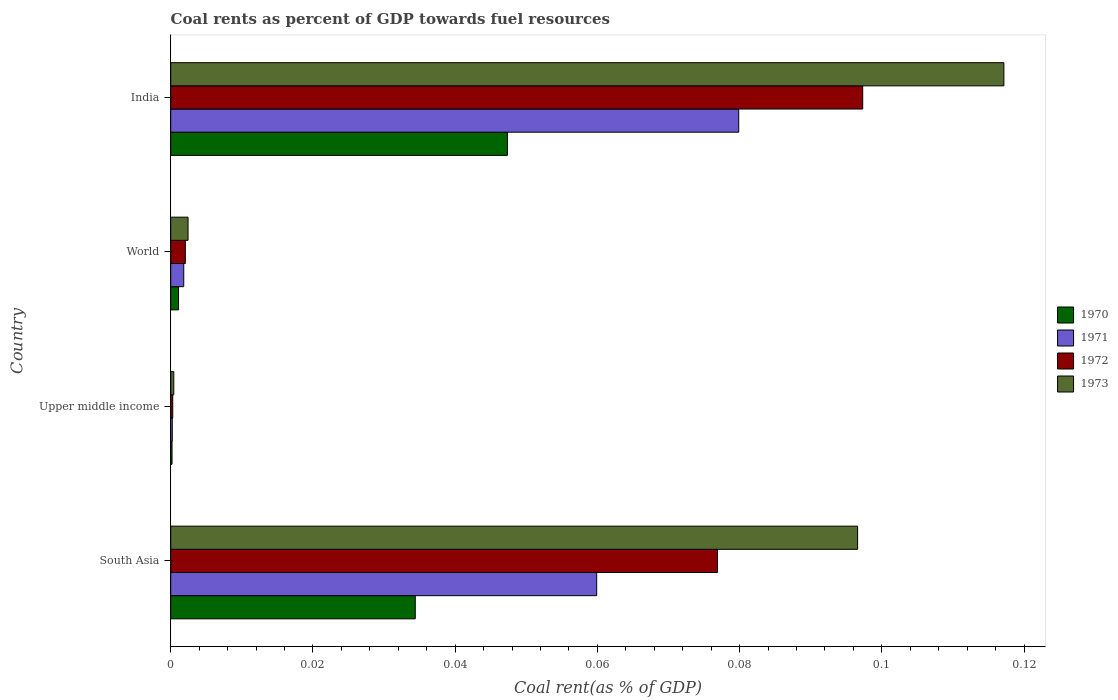How many different coloured bars are there?
Provide a succinct answer. 4. Are the number of bars per tick equal to the number of legend labels?
Your response must be concise. Yes. How many bars are there on the 1st tick from the top?
Offer a terse response. 4. How many bars are there on the 4th tick from the bottom?
Ensure brevity in your answer.  4. What is the label of the 1st group of bars from the top?
Offer a very short reply. India. What is the coal rent in 1971 in World?
Your answer should be very brief. 0. Across all countries, what is the maximum coal rent in 1971?
Provide a succinct answer. 0.08. Across all countries, what is the minimum coal rent in 1970?
Provide a succinct answer. 0. In which country was the coal rent in 1971 minimum?
Make the answer very short. Upper middle income. What is the total coal rent in 1972 in the graph?
Provide a succinct answer. 0.18. What is the difference between the coal rent in 1971 in India and that in Upper middle income?
Offer a very short reply. 0.08. What is the difference between the coal rent in 1971 in South Asia and the coal rent in 1970 in India?
Offer a very short reply. 0.01. What is the average coal rent in 1972 per country?
Your answer should be compact. 0.04. What is the difference between the coal rent in 1972 and coal rent in 1971 in India?
Your answer should be very brief. 0.02. What is the ratio of the coal rent in 1970 in India to that in Upper middle income?
Ensure brevity in your answer.  257.52. What is the difference between the highest and the second highest coal rent in 1970?
Offer a terse response. 0.01. What is the difference between the highest and the lowest coal rent in 1973?
Your answer should be very brief. 0.12. Is it the case that in every country, the sum of the coal rent in 1972 and coal rent in 1970 is greater than the sum of coal rent in 1971 and coal rent in 1973?
Your answer should be compact. No. What does the 3rd bar from the top in South Asia represents?
Offer a terse response. 1971. What does the 4th bar from the bottom in World represents?
Offer a terse response. 1973. Is it the case that in every country, the sum of the coal rent in 1972 and coal rent in 1973 is greater than the coal rent in 1970?
Provide a succinct answer. Yes. How many bars are there?
Your response must be concise. 16. How many countries are there in the graph?
Provide a succinct answer. 4. What is the difference between two consecutive major ticks on the X-axis?
Provide a short and direct response. 0.02. Does the graph contain any zero values?
Keep it short and to the point. No. Where does the legend appear in the graph?
Your response must be concise. Center right. How are the legend labels stacked?
Ensure brevity in your answer.  Vertical. What is the title of the graph?
Provide a succinct answer. Coal rents as percent of GDP towards fuel resources. Does "2003" appear as one of the legend labels in the graph?
Offer a very short reply. No. What is the label or title of the X-axis?
Keep it short and to the point. Coal rent(as % of GDP). What is the label or title of the Y-axis?
Your response must be concise. Country. What is the Coal rent(as % of GDP) in 1970 in South Asia?
Keep it short and to the point. 0.03. What is the Coal rent(as % of GDP) of 1971 in South Asia?
Offer a terse response. 0.06. What is the Coal rent(as % of GDP) in 1972 in South Asia?
Your response must be concise. 0.08. What is the Coal rent(as % of GDP) of 1973 in South Asia?
Your answer should be very brief. 0.1. What is the Coal rent(as % of GDP) of 1970 in Upper middle income?
Ensure brevity in your answer.  0. What is the Coal rent(as % of GDP) in 1971 in Upper middle income?
Offer a terse response. 0. What is the Coal rent(as % of GDP) of 1972 in Upper middle income?
Your response must be concise. 0. What is the Coal rent(as % of GDP) of 1973 in Upper middle income?
Your answer should be compact. 0. What is the Coal rent(as % of GDP) of 1970 in World?
Ensure brevity in your answer.  0. What is the Coal rent(as % of GDP) in 1971 in World?
Provide a succinct answer. 0. What is the Coal rent(as % of GDP) of 1972 in World?
Give a very brief answer. 0. What is the Coal rent(as % of GDP) of 1973 in World?
Your answer should be very brief. 0. What is the Coal rent(as % of GDP) in 1970 in India?
Your answer should be very brief. 0.05. What is the Coal rent(as % of GDP) in 1971 in India?
Keep it short and to the point. 0.08. What is the Coal rent(as % of GDP) in 1972 in India?
Provide a succinct answer. 0.1. What is the Coal rent(as % of GDP) in 1973 in India?
Your answer should be compact. 0.12. Across all countries, what is the maximum Coal rent(as % of GDP) of 1970?
Keep it short and to the point. 0.05. Across all countries, what is the maximum Coal rent(as % of GDP) of 1971?
Make the answer very short. 0.08. Across all countries, what is the maximum Coal rent(as % of GDP) in 1972?
Your response must be concise. 0.1. Across all countries, what is the maximum Coal rent(as % of GDP) of 1973?
Your answer should be very brief. 0.12. Across all countries, what is the minimum Coal rent(as % of GDP) in 1970?
Ensure brevity in your answer.  0. Across all countries, what is the minimum Coal rent(as % of GDP) in 1971?
Keep it short and to the point. 0. Across all countries, what is the minimum Coal rent(as % of GDP) of 1972?
Provide a short and direct response. 0. Across all countries, what is the minimum Coal rent(as % of GDP) of 1973?
Make the answer very short. 0. What is the total Coal rent(as % of GDP) of 1970 in the graph?
Ensure brevity in your answer.  0.08. What is the total Coal rent(as % of GDP) in 1971 in the graph?
Your answer should be very brief. 0.14. What is the total Coal rent(as % of GDP) in 1972 in the graph?
Your answer should be compact. 0.18. What is the total Coal rent(as % of GDP) of 1973 in the graph?
Your answer should be very brief. 0.22. What is the difference between the Coal rent(as % of GDP) in 1970 in South Asia and that in Upper middle income?
Make the answer very short. 0.03. What is the difference between the Coal rent(as % of GDP) in 1971 in South Asia and that in Upper middle income?
Keep it short and to the point. 0.06. What is the difference between the Coal rent(as % of GDP) of 1972 in South Asia and that in Upper middle income?
Ensure brevity in your answer.  0.08. What is the difference between the Coal rent(as % of GDP) of 1973 in South Asia and that in Upper middle income?
Provide a short and direct response. 0.1. What is the difference between the Coal rent(as % of GDP) in 1970 in South Asia and that in World?
Provide a short and direct response. 0.03. What is the difference between the Coal rent(as % of GDP) of 1971 in South Asia and that in World?
Your answer should be very brief. 0.06. What is the difference between the Coal rent(as % of GDP) of 1972 in South Asia and that in World?
Make the answer very short. 0.07. What is the difference between the Coal rent(as % of GDP) in 1973 in South Asia and that in World?
Offer a very short reply. 0.09. What is the difference between the Coal rent(as % of GDP) of 1970 in South Asia and that in India?
Offer a terse response. -0.01. What is the difference between the Coal rent(as % of GDP) of 1971 in South Asia and that in India?
Provide a short and direct response. -0.02. What is the difference between the Coal rent(as % of GDP) of 1972 in South Asia and that in India?
Make the answer very short. -0.02. What is the difference between the Coal rent(as % of GDP) in 1973 in South Asia and that in India?
Your response must be concise. -0.02. What is the difference between the Coal rent(as % of GDP) in 1970 in Upper middle income and that in World?
Make the answer very short. -0. What is the difference between the Coal rent(as % of GDP) of 1971 in Upper middle income and that in World?
Make the answer very short. -0. What is the difference between the Coal rent(as % of GDP) of 1972 in Upper middle income and that in World?
Provide a succinct answer. -0. What is the difference between the Coal rent(as % of GDP) in 1973 in Upper middle income and that in World?
Provide a succinct answer. -0. What is the difference between the Coal rent(as % of GDP) in 1970 in Upper middle income and that in India?
Provide a succinct answer. -0.05. What is the difference between the Coal rent(as % of GDP) of 1971 in Upper middle income and that in India?
Make the answer very short. -0.08. What is the difference between the Coal rent(as % of GDP) in 1972 in Upper middle income and that in India?
Your response must be concise. -0.1. What is the difference between the Coal rent(as % of GDP) in 1973 in Upper middle income and that in India?
Your response must be concise. -0.12. What is the difference between the Coal rent(as % of GDP) in 1970 in World and that in India?
Offer a terse response. -0.05. What is the difference between the Coal rent(as % of GDP) of 1971 in World and that in India?
Keep it short and to the point. -0.08. What is the difference between the Coal rent(as % of GDP) in 1972 in World and that in India?
Ensure brevity in your answer.  -0.1. What is the difference between the Coal rent(as % of GDP) in 1973 in World and that in India?
Give a very brief answer. -0.11. What is the difference between the Coal rent(as % of GDP) of 1970 in South Asia and the Coal rent(as % of GDP) of 1971 in Upper middle income?
Your answer should be very brief. 0.03. What is the difference between the Coal rent(as % of GDP) in 1970 in South Asia and the Coal rent(as % of GDP) in 1972 in Upper middle income?
Ensure brevity in your answer.  0.03. What is the difference between the Coal rent(as % of GDP) in 1970 in South Asia and the Coal rent(as % of GDP) in 1973 in Upper middle income?
Ensure brevity in your answer.  0.03. What is the difference between the Coal rent(as % of GDP) in 1971 in South Asia and the Coal rent(as % of GDP) in 1972 in Upper middle income?
Your response must be concise. 0.06. What is the difference between the Coal rent(as % of GDP) in 1971 in South Asia and the Coal rent(as % of GDP) in 1973 in Upper middle income?
Offer a very short reply. 0.06. What is the difference between the Coal rent(as % of GDP) in 1972 in South Asia and the Coal rent(as % of GDP) in 1973 in Upper middle income?
Your response must be concise. 0.08. What is the difference between the Coal rent(as % of GDP) of 1970 in South Asia and the Coal rent(as % of GDP) of 1971 in World?
Give a very brief answer. 0.03. What is the difference between the Coal rent(as % of GDP) of 1970 in South Asia and the Coal rent(as % of GDP) of 1972 in World?
Give a very brief answer. 0.03. What is the difference between the Coal rent(as % of GDP) in 1970 in South Asia and the Coal rent(as % of GDP) in 1973 in World?
Offer a very short reply. 0.03. What is the difference between the Coal rent(as % of GDP) of 1971 in South Asia and the Coal rent(as % of GDP) of 1972 in World?
Offer a terse response. 0.06. What is the difference between the Coal rent(as % of GDP) of 1971 in South Asia and the Coal rent(as % of GDP) of 1973 in World?
Offer a terse response. 0.06. What is the difference between the Coal rent(as % of GDP) of 1972 in South Asia and the Coal rent(as % of GDP) of 1973 in World?
Offer a terse response. 0.07. What is the difference between the Coal rent(as % of GDP) of 1970 in South Asia and the Coal rent(as % of GDP) of 1971 in India?
Keep it short and to the point. -0.05. What is the difference between the Coal rent(as % of GDP) in 1970 in South Asia and the Coal rent(as % of GDP) in 1972 in India?
Make the answer very short. -0.06. What is the difference between the Coal rent(as % of GDP) in 1970 in South Asia and the Coal rent(as % of GDP) in 1973 in India?
Offer a very short reply. -0.08. What is the difference between the Coal rent(as % of GDP) of 1971 in South Asia and the Coal rent(as % of GDP) of 1972 in India?
Your response must be concise. -0.04. What is the difference between the Coal rent(as % of GDP) in 1971 in South Asia and the Coal rent(as % of GDP) in 1973 in India?
Offer a terse response. -0.06. What is the difference between the Coal rent(as % of GDP) of 1972 in South Asia and the Coal rent(as % of GDP) of 1973 in India?
Offer a terse response. -0.04. What is the difference between the Coal rent(as % of GDP) of 1970 in Upper middle income and the Coal rent(as % of GDP) of 1971 in World?
Offer a very short reply. -0. What is the difference between the Coal rent(as % of GDP) in 1970 in Upper middle income and the Coal rent(as % of GDP) in 1972 in World?
Make the answer very short. -0. What is the difference between the Coal rent(as % of GDP) in 1970 in Upper middle income and the Coal rent(as % of GDP) in 1973 in World?
Your answer should be very brief. -0. What is the difference between the Coal rent(as % of GDP) of 1971 in Upper middle income and the Coal rent(as % of GDP) of 1972 in World?
Your answer should be compact. -0. What is the difference between the Coal rent(as % of GDP) of 1971 in Upper middle income and the Coal rent(as % of GDP) of 1973 in World?
Give a very brief answer. -0. What is the difference between the Coal rent(as % of GDP) of 1972 in Upper middle income and the Coal rent(as % of GDP) of 1973 in World?
Your answer should be very brief. -0. What is the difference between the Coal rent(as % of GDP) in 1970 in Upper middle income and the Coal rent(as % of GDP) in 1971 in India?
Give a very brief answer. -0.08. What is the difference between the Coal rent(as % of GDP) of 1970 in Upper middle income and the Coal rent(as % of GDP) of 1972 in India?
Your answer should be very brief. -0.1. What is the difference between the Coal rent(as % of GDP) in 1970 in Upper middle income and the Coal rent(as % of GDP) in 1973 in India?
Give a very brief answer. -0.12. What is the difference between the Coal rent(as % of GDP) of 1971 in Upper middle income and the Coal rent(as % of GDP) of 1972 in India?
Your answer should be compact. -0.1. What is the difference between the Coal rent(as % of GDP) of 1971 in Upper middle income and the Coal rent(as % of GDP) of 1973 in India?
Give a very brief answer. -0.12. What is the difference between the Coal rent(as % of GDP) of 1972 in Upper middle income and the Coal rent(as % of GDP) of 1973 in India?
Ensure brevity in your answer.  -0.12. What is the difference between the Coal rent(as % of GDP) in 1970 in World and the Coal rent(as % of GDP) in 1971 in India?
Offer a very short reply. -0.08. What is the difference between the Coal rent(as % of GDP) in 1970 in World and the Coal rent(as % of GDP) in 1972 in India?
Offer a very short reply. -0.1. What is the difference between the Coal rent(as % of GDP) of 1970 in World and the Coal rent(as % of GDP) of 1973 in India?
Keep it short and to the point. -0.12. What is the difference between the Coal rent(as % of GDP) in 1971 in World and the Coal rent(as % of GDP) in 1972 in India?
Provide a succinct answer. -0.1. What is the difference between the Coal rent(as % of GDP) of 1971 in World and the Coal rent(as % of GDP) of 1973 in India?
Give a very brief answer. -0.12. What is the difference between the Coal rent(as % of GDP) in 1972 in World and the Coal rent(as % of GDP) in 1973 in India?
Keep it short and to the point. -0.12. What is the average Coal rent(as % of GDP) of 1970 per country?
Ensure brevity in your answer.  0.02. What is the average Coal rent(as % of GDP) of 1971 per country?
Provide a succinct answer. 0.04. What is the average Coal rent(as % of GDP) in 1972 per country?
Keep it short and to the point. 0.04. What is the average Coal rent(as % of GDP) of 1973 per country?
Your answer should be very brief. 0.05. What is the difference between the Coal rent(as % of GDP) of 1970 and Coal rent(as % of GDP) of 1971 in South Asia?
Your answer should be compact. -0.03. What is the difference between the Coal rent(as % of GDP) in 1970 and Coal rent(as % of GDP) in 1972 in South Asia?
Offer a very short reply. -0.04. What is the difference between the Coal rent(as % of GDP) of 1970 and Coal rent(as % of GDP) of 1973 in South Asia?
Offer a very short reply. -0.06. What is the difference between the Coal rent(as % of GDP) of 1971 and Coal rent(as % of GDP) of 1972 in South Asia?
Ensure brevity in your answer.  -0.02. What is the difference between the Coal rent(as % of GDP) in 1971 and Coal rent(as % of GDP) in 1973 in South Asia?
Provide a succinct answer. -0.04. What is the difference between the Coal rent(as % of GDP) of 1972 and Coal rent(as % of GDP) of 1973 in South Asia?
Offer a terse response. -0.02. What is the difference between the Coal rent(as % of GDP) of 1970 and Coal rent(as % of GDP) of 1972 in Upper middle income?
Keep it short and to the point. -0. What is the difference between the Coal rent(as % of GDP) in 1970 and Coal rent(as % of GDP) in 1973 in Upper middle income?
Make the answer very short. -0. What is the difference between the Coal rent(as % of GDP) in 1971 and Coal rent(as % of GDP) in 1972 in Upper middle income?
Make the answer very short. -0. What is the difference between the Coal rent(as % of GDP) of 1971 and Coal rent(as % of GDP) of 1973 in Upper middle income?
Give a very brief answer. -0. What is the difference between the Coal rent(as % of GDP) of 1972 and Coal rent(as % of GDP) of 1973 in Upper middle income?
Give a very brief answer. -0. What is the difference between the Coal rent(as % of GDP) in 1970 and Coal rent(as % of GDP) in 1971 in World?
Your response must be concise. -0. What is the difference between the Coal rent(as % of GDP) of 1970 and Coal rent(as % of GDP) of 1972 in World?
Provide a succinct answer. -0. What is the difference between the Coal rent(as % of GDP) in 1970 and Coal rent(as % of GDP) in 1973 in World?
Offer a terse response. -0. What is the difference between the Coal rent(as % of GDP) in 1971 and Coal rent(as % of GDP) in 1972 in World?
Your response must be concise. -0. What is the difference between the Coal rent(as % of GDP) in 1971 and Coal rent(as % of GDP) in 1973 in World?
Offer a terse response. -0. What is the difference between the Coal rent(as % of GDP) in 1972 and Coal rent(as % of GDP) in 1973 in World?
Offer a terse response. -0. What is the difference between the Coal rent(as % of GDP) in 1970 and Coal rent(as % of GDP) in 1971 in India?
Your answer should be compact. -0.03. What is the difference between the Coal rent(as % of GDP) in 1970 and Coal rent(as % of GDP) in 1973 in India?
Give a very brief answer. -0.07. What is the difference between the Coal rent(as % of GDP) of 1971 and Coal rent(as % of GDP) of 1972 in India?
Provide a short and direct response. -0.02. What is the difference between the Coal rent(as % of GDP) of 1971 and Coal rent(as % of GDP) of 1973 in India?
Keep it short and to the point. -0.04. What is the difference between the Coal rent(as % of GDP) in 1972 and Coal rent(as % of GDP) in 1973 in India?
Give a very brief answer. -0.02. What is the ratio of the Coal rent(as % of GDP) in 1970 in South Asia to that in Upper middle income?
Make the answer very short. 187.05. What is the ratio of the Coal rent(as % of GDP) in 1971 in South Asia to that in Upper middle income?
Ensure brevity in your answer.  273.74. What is the ratio of the Coal rent(as % of GDP) of 1972 in South Asia to that in Upper middle income?
Your answer should be compact. 270.32. What is the ratio of the Coal rent(as % of GDP) of 1973 in South Asia to that in Upper middle income?
Your response must be concise. 224.18. What is the ratio of the Coal rent(as % of GDP) in 1970 in South Asia to that in World?
Provide a short and direct response. 31.24. What is the ratio of the Coal rent(as % of GDP) in 1971 in South Asia to that in World?
Your answer should be very brief. 32.69. What is the ratio of the Coal rent(as % of GDP) in 1972 in South Asia to that in World?
Ensure brevity in your answer.  37.41. What is the ratio of the Coal rent(as % of GDP) of 1973 in South Asia to that in World?
Ensure brevity in your answer.  39.65. What is the ratio of the Coal rent(as % of GDP) of 1970 in South Asia to that in India?
Ensure brevity in your answer.  0.73. What is the ratio of the Coal rent(as % of GDP) in 1971 in South Asia to that in India?
Your answer should be very brief. 0.75. What is the ratio of the Coal rent(as % of GDP) in 1972 in South Asia to that in India?
Your response must be concise. 0.79. What is the ratio of the Coal rent(as % of GDP) of 1973 in South Asia to that in India?
Offer a terse response. 0.82. What is the ratio of the Coal rent(as % of GDP) in 1970 in Upper middle income to that in World?
Your answer should be very brief. 0.17. What is the ratio of the Coal rent(as % of GDP) in 1971 in Upper middle income to that in World?
Your response must be concise. 0.12. What is the ratio of the Coal rent(as % of GDP) in 1972 in Upper middle income to that in World?
Give a very brief answer. 0.14. What is the ratio of the Coal rent(as % of GDP) of 1973 in Upper middle income to that in World?
Your answer should be very brief. 0.18. What is the ratio of the Coal rent(as % of GDP) in 1970 in Upper middle income to that in India?
Offer a very short reply. 0. What is the ratio of the Coal rent(as % of GDP) of 1971 in Upper middle income to that in India?
Keep it short and to the point. 0. What is the ratio of the Coal rent(as % of GDP) of 1972 in Upper middle income to that in India?
Keep it short and to the point. 0. What is the ratio of the Coal rent(as % of GDP) in 1973 in Upper middle income to that in India?
Provide a succinct answer. 0. What is the ratio of the Coal rent(as % of GDP) in 1970 in World to that in India?
Offer a very short reply. 0.02. What is the ratio of the Coal rent(as % of GDP) of 1971 in World to that in India?
Make the answer very short. 0.02. What is the ratio of the Coal rent(as % of GDP) in 1972 in World to that in India?
Your answer should be very brief. 0.02. What is the ratio of the Coal rent(as % of GDP) in 1973 in World to that in India?
Your response must be concise. 0.02. What is the difference between the highest and the second highest Coal rent(as % of GDP) in 1970?
Offer a terse response. 0.01. What is the difference between the highest and the second highest Coal rent(as % of GDP) in 1971?
Provide a succinct answer. 0.02. What is the difference between the highest and the second highest Coal rent(as % of GDP) of 1972?
Provide a succinct answer. 0.02. What is the difference between the highest and the second highest Coal rent(as % of GDP) in 1973?
Offer a very short reply. 0.02. What is the difference between the highest and the lowest Coal rent(as % of GDP) of 1970?
Offer a very short reply. 0.05. What is the difference between the highest and the lowest Coal rent(as % of GDP) of 1971?
Offer a terse response. 0.08. What is the difference between the highest and the lowest Coal rent(as % of GDP) in 1972?
Offer a very short reply. 0.1. What is the difference between the highest and the lowest Coal rent(as % of GDP) of 1973?
Your answer should be very brief. 0.12. 